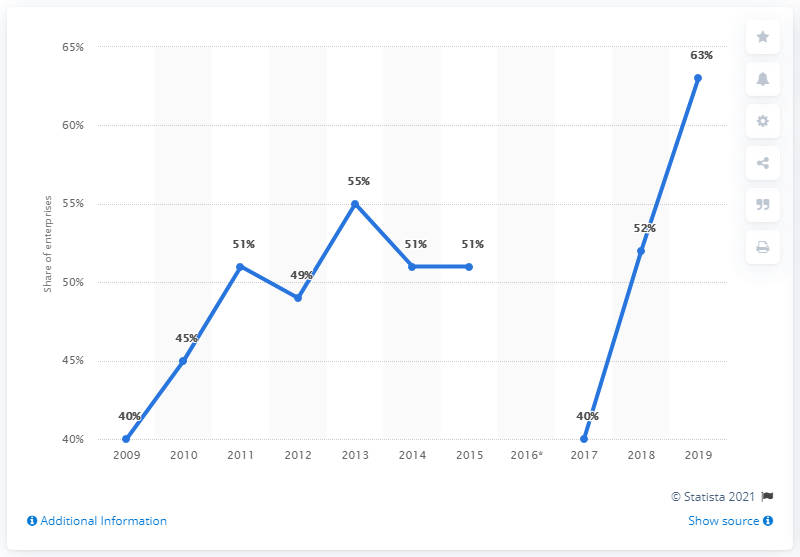Outline some significant characteristics in this image. The difference between the highest and lowest projected share of enterprises is 23%. The blue line graph reached its highest peak in the year 2019. 